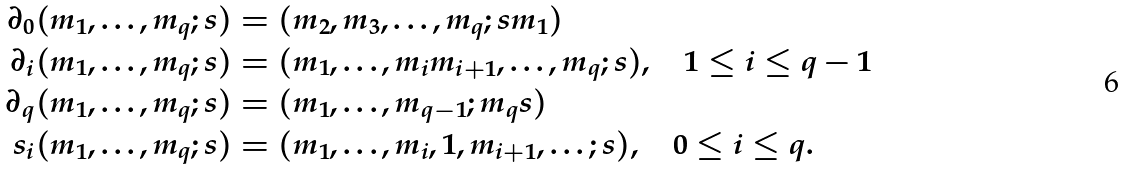<formula> <loc_0><loc_0><loc_500><loc_500>\partial _ { 0 } ( m _ { 1 } , \dots , m _ { q } ; s ) & = ( m _ { 2 } , m _ { 3 } , \dots , m _ { q } ; s m _ { 1 } ) \\ \partial _ { i } ( m _ { 1 } , \dots , m _ { q } ; s ) & = ( m _ { 1 } , \dots , m _ { i } m _ { i + 1 } , \dots , m _ { q } ; s ) , \quad 1 \leq i \leq q - 1 \\ \partial _ { q } ( m _ { 1 } , \dots , m _ { q } ; s ) & = ( m _ { 1 } , \dots , m _ { q - 1 } ; m _ { q } s ) \\ s _ { i } ( m _ { 1 } , \dots , m _ { q } ; s ) & = ( m _ { 1 } , \dots , m _ { i } , 1 , m _ { i + 1 } , \dots ; s ) , \quad 0 \leq i \leq q .</formula> 